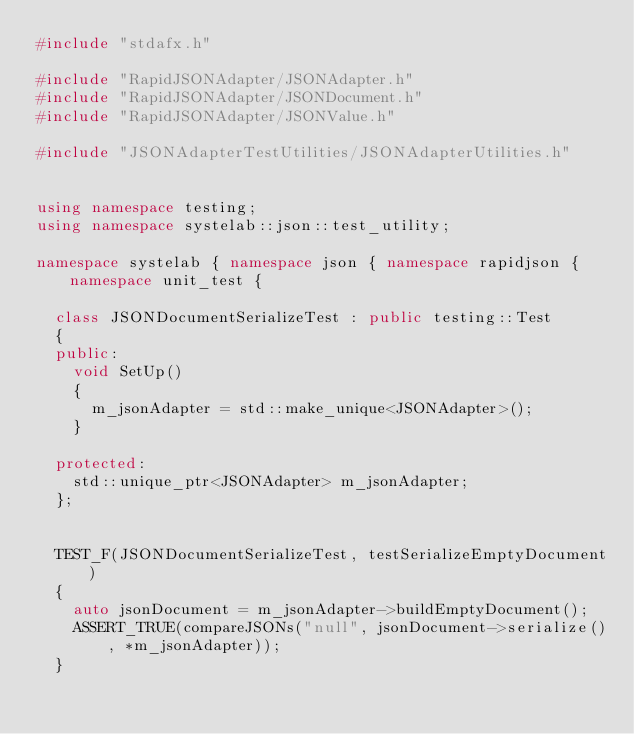Convert code to text. <code><loc_0><loc_0><loc_500><loc_500><_C++_>#include "stdafx.h"

#include "RapidJSONAdapter/JSONAdapter.h"
#include "RapidJSONAdapter/JSONDocument.h"
#include "RapidJSONAdapter/JSONValue.h"

#include "JSONAdapterTestUtilities/JSONAdapterUtilities.h"


using namespace testing;
using namespace systelab::json::test_utility;

namespace systelab { namespace json { namespace rapidjson { namespace unit_test {

	class JSONDocumentSerializeTest : public testing::Test
	{
	public:
		void SetUp()
		{
			m_jsonAdapter = std::make_unique<JSONAdapter>();
		}

	protected:
		std::unique_ptr<JSONAdapter> m_jsonAdapter;
	};


	TEST_F(JSONDocumentSerializeTest, testSerializeEmptyDocument)
	{
		auto jsonDocument = m_jsonAdapter->buildEmptyDocument();
		ASSERT_TRUE(compareJSONs("null", jsonDocument->serialize(), *m_jsonAdapter));
	}
</code> 